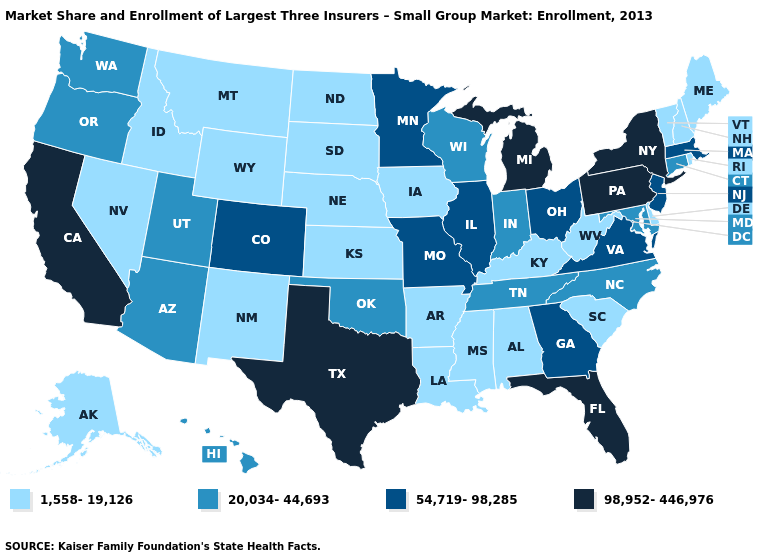Does Texas have the lowest value in the USA?
Short answer required. No. What is the value of Oklahoma?
Give a very brief answer. 20,034-44,693. Does the first symbol in the legend represent the smallest category?
Answer briefly. Yes. What is the highest value in the USA?
Short answer required. 98,952-446,976. Does Kansas have the lowest value in the USA?
Short answer required. Yes. Among the states that border West Virginia , does Pennsylvania have the highest value?
Concise answer only. Yes. Does Wyoming have the lowest value in the West?
Write a very short answer. Yes. Does Michigan have the highest value in the MidWest?
Answer briefly. Yes. What is the highest value in the USA?
Keep it brief. 98,952-446,976. What is the highest value in the USA?
Give a very brief answer. 98,952-446,976. Name the states that have a value in the range 1,558-19,126?
Answer briefly. Alabama, Alaska, Arkansas, Delaware, Idaho, Iowa, Kansas, Kentucky, Louisiana, Maine, Mississippi, Montana, Nebraska, Nevada, New Hampshire, New Mexico, North Dakota, Rhode Island, South Carolina, South Dakota, Vermont, West Virginia, Wyoming. How many symbols are there in the legend?
Give a very brief answer. 4. Which states hav the highest value in the MidWest?
Be succinct. Michigan. Name the states that have a value in the range 98,952-446,976?
Be succinct. California, Florida, Michigan, New York, Pennsylvania, Texas. What is the lowest value in the West?
Concise answer only. 1,558-19,126. 